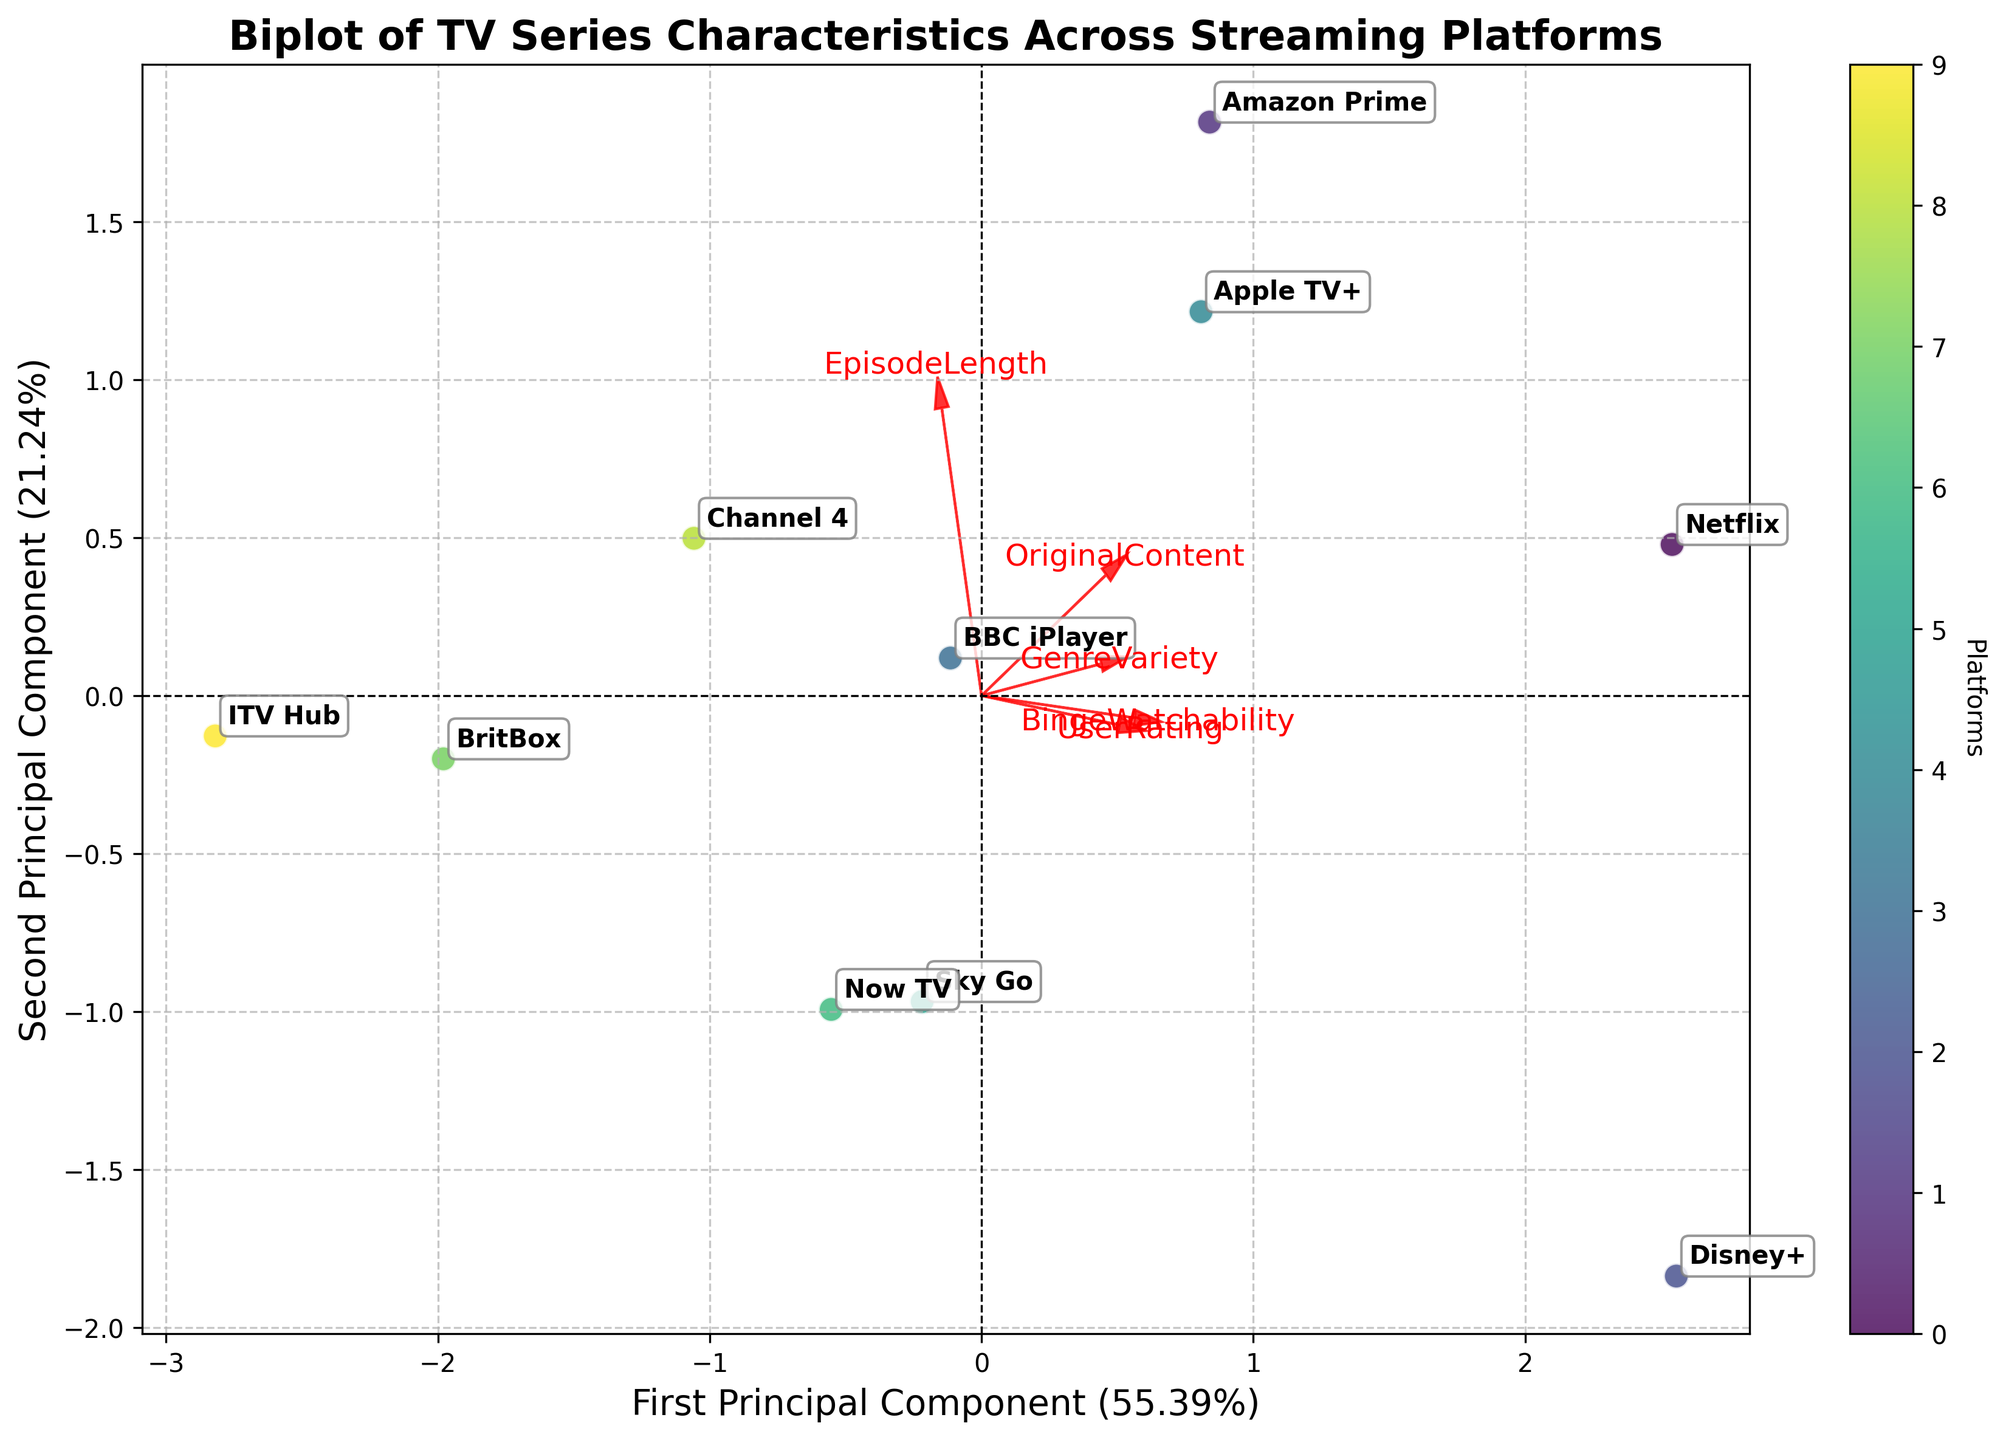Which platform corresponds to the point furthest to the right on the first principal component axis? The point furthest to the right on the first principal component axis can be identified by looking at the scatter points' horizontal spread. The label next to the most rightward point is "Channel 4".
Answer: Channel 4 Which streaming platform has the highest User Rating based on the plot? To find the platform with the highest User Rating, look at the direction of the "UserRating" arrow. The platform closest to the direction of this arrow is "Disney+" as it is located near the end of the arrow.
Answer: Disney+ How many streaming platforms are represented in the plot? Count the number of distinct annotated labels on the biplot. There are labels for Netflix, Amazon Prime, Disney+, BBC iPlayer, Apple TV+, Sky Go, Now TV, BritBox, Channel 4, and ITV Hub, which totals to 10.
Answer: 10 Which platform is positioned closest to the origin of the plot? The plot's origin is the center point of both PC1 and PC2 axes. The platform label closest to this central point is "Sky Go".
Answer: Sky Go Are "Netflix" and "Channel 4" closer to each other compared to "Disney+" and "Amazon Prime"? Measure the distance between "Netflix" and "Channel 4" and compare it to the distance between "Disney+" and "Amazon Prime" by their positions on the plot. "Netflix" and "Channel 4" are closer to each other compared to "Disney+" and "Amazon Prime".
Answer: Yes, Netflix and Channel 4 are closer What streaming platform shows a strong tilt towards high Binge Watchability? The "BingeWatchability" arrow points towards higher levels of this feature. The streaming platform located near the end of this arrow is "Disney+".
Answer: Disney+ Which platform lies closest to the "OriginalContent" vector? The "OriginalContent" vector points diagonally, and the platform close to this direction is "Netflix".
Answer: Netflix Which two platforms have the most similar characteristics based on their position in the plot? Platforms that are very close together have similar characteristics. Observing their labels, "BritBox" and "ITV Hub" are the closest pair.
Answer: BritBox and ITV Hub How do "BBC iPlayer" and "Apple TV+" compare in terms of "GenreVariety"? The arrow for "GenreVariety" points in a certain direction, and comparing the proximity of "BBC iPlayer" and "Apple TV+" to that arrow, "BBC iPlayer" is closer than "Apple TV+".
Answer: BBC iPlayer has higher GenreVariety 